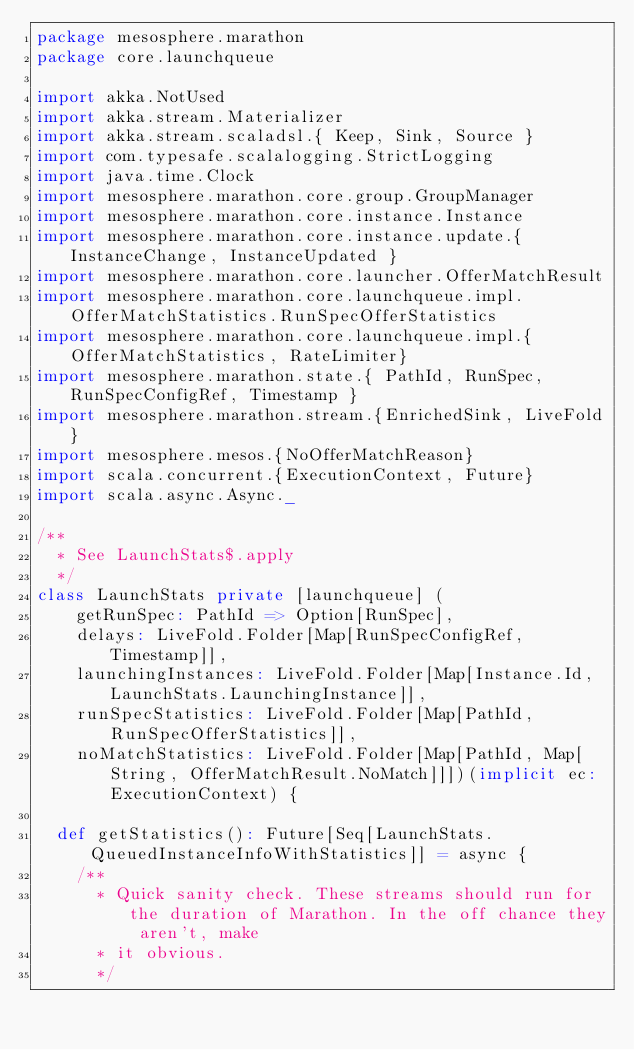Convert code to text. <code><loc_0><loc_0><loc_500><loc_500><_Scala_>package mesosphere.marathon
package core.launchqueue

import akka.NotUsed
import akka.stream.Materializer
import akka.stream.scaladsl.{ Keep, Sink, Source }
import com.typesafe.scalalogging.StrictLogging
import java.time.Clock
import mesosphere.marathon.core.group.GroupManager
import mesosphere.marathon.core.instance.Instance
import mesosphere.marathon.core.instance.update.{ InstanceChange, InstanceUpdated }
import mesosphere.marathon.core.launcher.OfferMatchResult
import mesosphere.marathon.core.launchqueue.impl.OfferMatchStatistics.RunSpecOfferStatistics
import mesosphere.marathon.core.launchqueue.impl.{OfferMatchStatistics, RateLimiter}
import mesosphere.marathon.state.{ PathId, RunSpec, RunSpecConfigRef, Timestamp }
import mesosphere.marathon.stream.{EnrichedSink, LiveFold}
import mesosphere.mesos.{NoOfferMatchReason}
import scala.concurrent.{ExecutionContext, Future}
import scala.async.Async._

/**
  * See LaunchStats$.apply
  */
class LaunchStats private [launchqueue] (
    getRunSpec: PathId => Option[RunSpec],
    delays: LiveFold.Folder[Map[RunSpecConfigRef, Timestamp]],
    launchingInstances: LiveFold.Folder[Map[Instance.Id, LaunchStats.LaunchingInstance]],
    runSpecStatistics: LiveFold.Folder[Map[PathId, RunSpecOfferStatistics]],
    noMatchStatistics: LiveFold.Folder[Map[PathId, Map[String, OfferMatchResult.NoMatch]]])(implicit ec: ExecutionContext) {

  def getStatistics(): Future[Seq[LaunchStats.QueuedInstanceInfoWithStatistics]] = async {
    /**
      * Quick sanity check. These streams should run for the duration of Marathon. In the off chance they aren't, make
      * it obvious.
      */</code> 